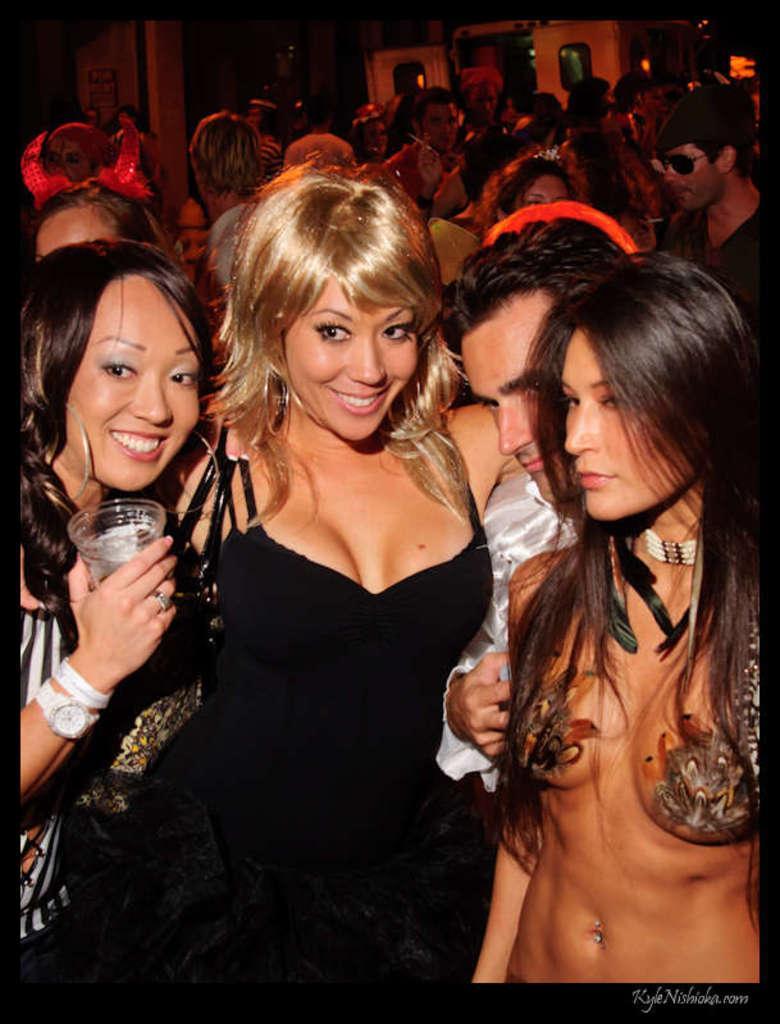How would you summarize this image in a sentence or two? In this image, we can see some people. We can see the wall and doors. We can also see some text written on the bottom right corner. 